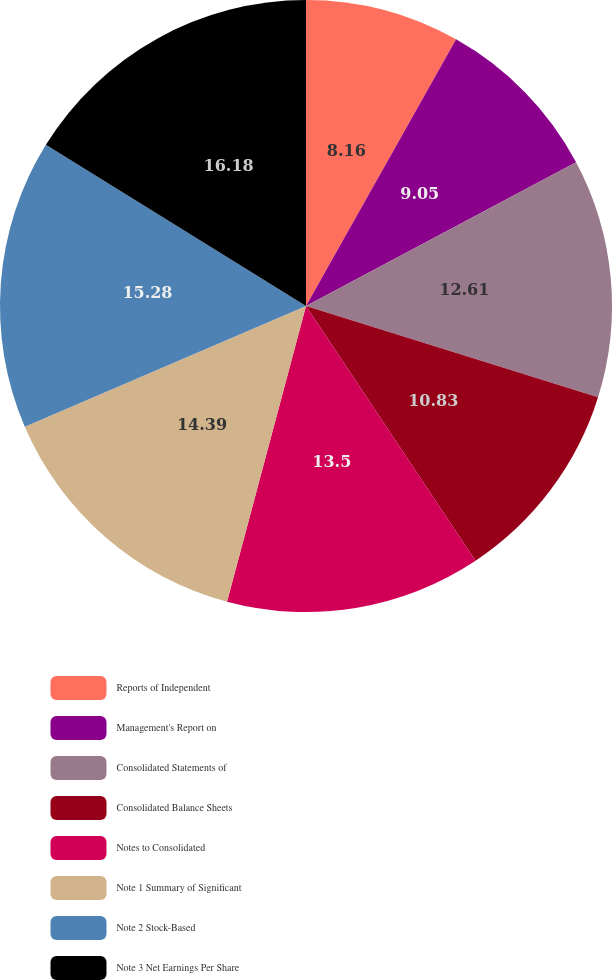<chart> <loc_0><loc_0><loc_500><loc_500><pie_chart><fcel>Reports of Independent<fcel>Management's Report on<fcel>Consolidated Statements of<fcel>Consolidated Balance Sheets<fcel>Notes to Consolidated<fcel>Note 1 Summary of Significant<fcel>Note 2 Stock-Based<fcel>Note 3 Net Earnings Per Share<nl><fcel>8.16%<fcel>9.05%<fcel>12.61%<fcel>10.83%<fcel>13.5%<fcel>14.39%<fcel>15.28%<fcel>16.17%<nl></chart> 